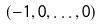Convert formula to latex. <formula><loc_0><loc_0><loc_500><loc_500>( - 1 , 0 , \dots , 0 )</formula> 